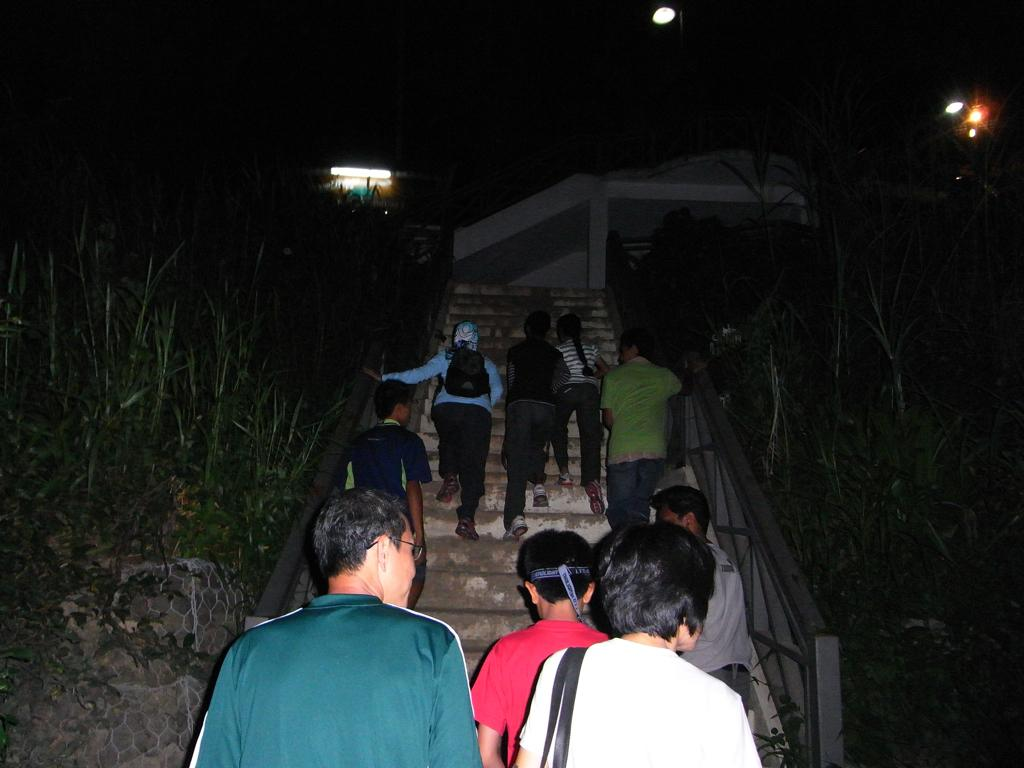What are the people in the image doing? There are people climbing stairs in the image. What can be seen on both sides of the stairs? Trees are present on both sides of the stairs. What is visible in the background of the image? There are buildings visible in the background of the image. What might be used to illuminate the area in the image? There are lights present in the image. Where are the cherries located in the image? There are no cherries present in the image. What type of drain can be seen in the image? There is no drain present in the image. 